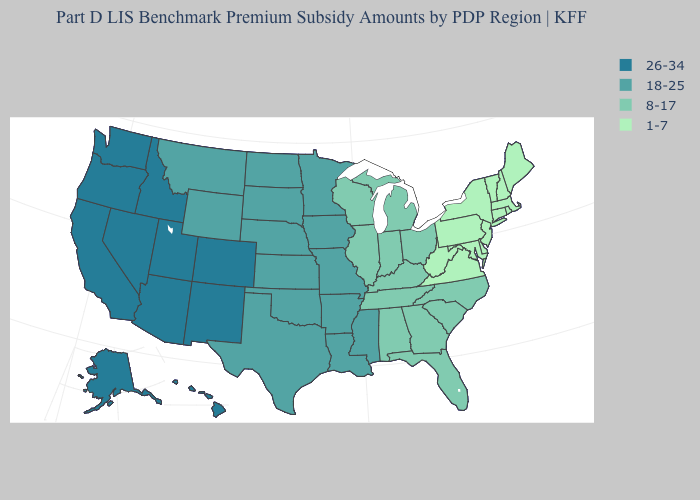Does the first symbol in the legend represent the smallest category?
Concise answer only. No. Name the states that have a value in the range 26-34?
Answer briefly. Alaska, Arizona, California, Colorado, Hawaii, Idaho, Nevada, New Mexico, Oregon, Utah, Washington. What is the value of Idaho?
Give a very brief answer. 26-34. What is the value of Delaware?
Answer briefly. 1-7. Name the states that have a value in the range 1-7?
Give a very brief answer. Connecticut, Delaware, Maine, Maryland, Massachusetts, New Hampshire, New Jersey, New York, Pennsylvania, Rhode Island, Vermont, Virginia, West Virginia. Name the states that have a value in the range 26-34?
Keep it brief. Alaska, Arizona, California, Colorado, Hawaii, Idaho, Nevada, New Mexico, Oregon, Utah, Washington. Which states have the lowest value in the USA?
Concise answer only. Connecticut, Delaware, Maine, Maryland, Massachusetts, New Hampshire, New Jersey, New York, Pennsylvania, Rhode Island, Vermont, Virginia, West Virginia. What is the lowest value in the USA?
Keep it brief. 1-7. Name the states that have a value in the range 8-17?
Answer briefly. Alabama, Florida, Georgia, Illinois, Indiana, Kentucky, Michigan, North Carolina, Ohio, South Carolina, Tennessee, Wisconsin. Name the states that have a value in the range 8-17?
Answer briefly. Alabama, Florida, Georgia, Illinois, Indiana, Kentucky, Michigan, North Carolina, Ohio, South Carolina, Tennessee, Wisconsin. What is the value of Georgia?
Short answer required. 8-17. What is the value of Iowa?
Be succinct. 18-25. What is the highest value in states that border Wyoming?
Answer briefly. 26-34. What is the value of Rhode Island?
Keep it brief. 1-7. Does Delaware have the highest value in the USA?
Concise answer only. No. 